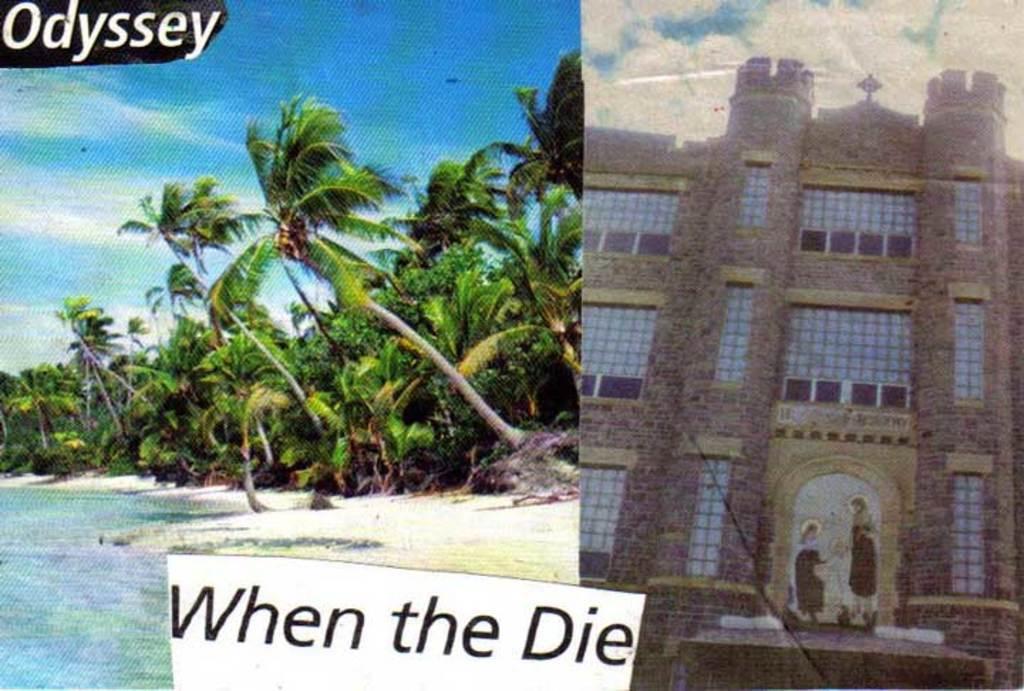In one or two sentences, can you explain what this image depicts? This is a collage image. There are trees,water. To the right side of the image there is a building. At the bottom of the image there is text. 